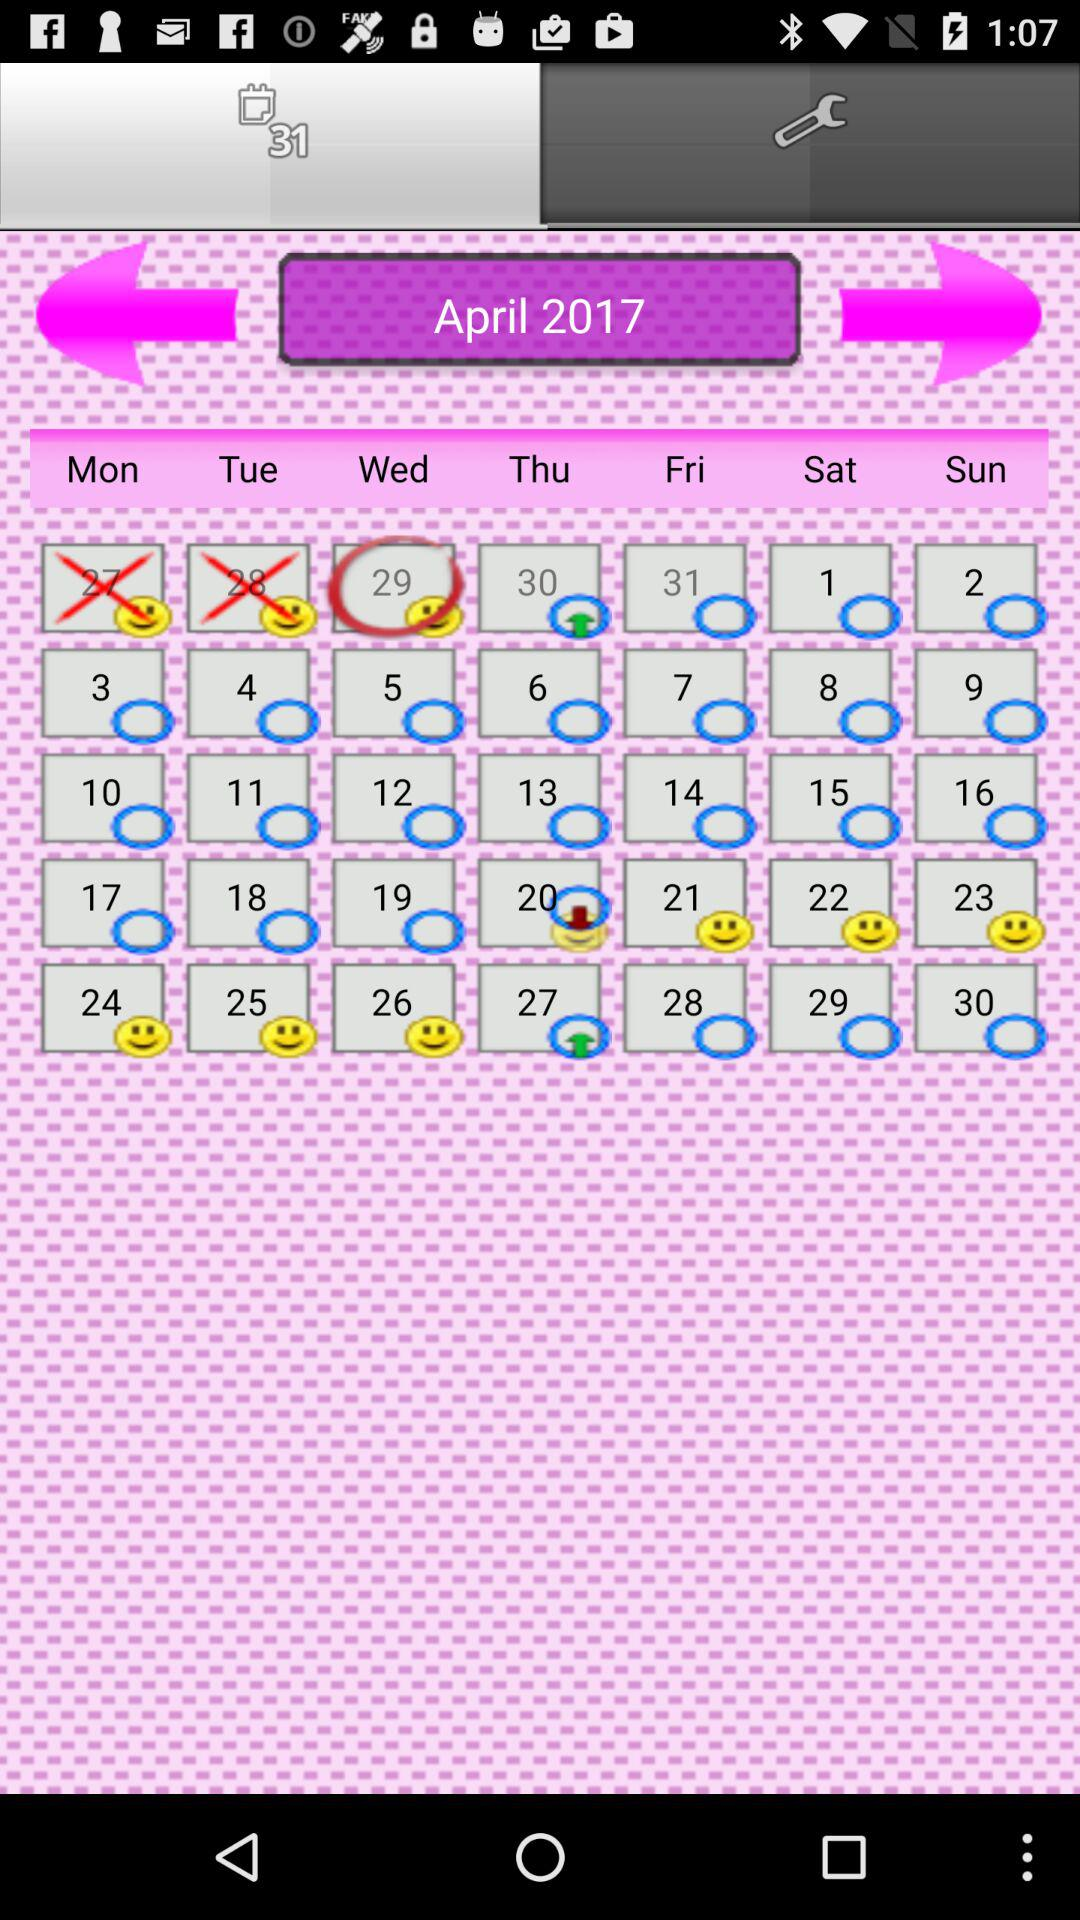What is the year? The year is 2017. 